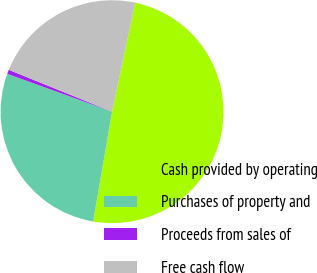Convert chart. <chart><loc_0><loc_0><loc_500><loc_500><pie_chart><fcel>Cash provided by operating<fcel>Purchases of property and<fcel>Proceeds from sales of<fcel>Free cash flow<nl><fcel>49.38%<fcel>27.8%<fcel>0.62%<fcel>22.2%<nl></chart> 